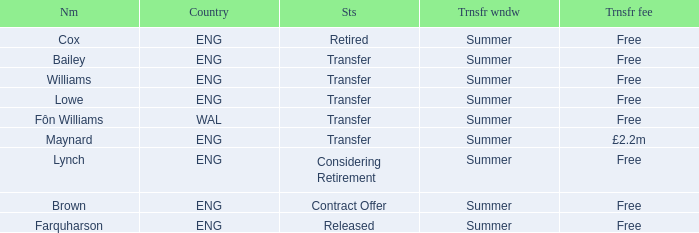What is the name of the free transfer fee with a transfer status and an ENG country? Bailey, Williams, Lowe. 